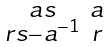<formula> <loc_0><loc_0><loc_500><loc_500>\begin{smallmatrix} a s & a \\ r s - a ^ { - 1 } & r \end{smallmatrix}</formula> 